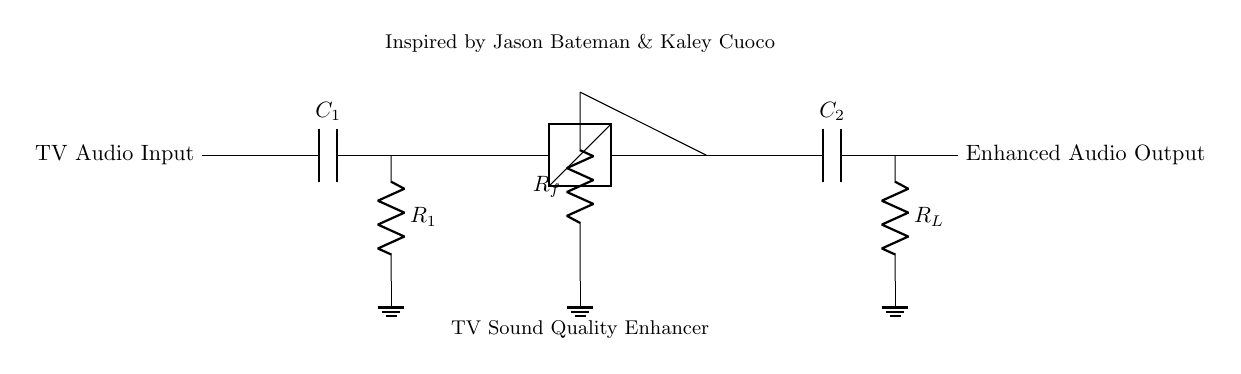What is the first component in the circuit? The circuit shows that the first component is a capacitor labeled C1, which is connected directly to the TV audio input.
Answer: C1 What type of amplifier is shown in the circuit? The circuit includes a component labeled as an "Op-Amp," indicating that this is an operational amplifier used to enhance audio quality.
Answer: Operational amplifier What is the purpose of resistor Rf in the circuit? Resistor Rf is connected to the op-amp and is part of the feedback mechanism, typically influencing the gain of the amplifier.
Answer: Gain adjustment How many capacitors are in the circuit? The diagram displays two capacitors, C1 and C2, used at different points in the audio signal path.
Answer: 2 What connects the output of the op-amp to Rl? The output of the op-amp is connected to Rl (the load resistor) through a short connection, allowing the amplified signal to pass through to the load.
Answer: A short connection What is located at the enhanced audio output? At the enhanced audio output, the signal has already passed through the circuit and is now ready for further transmission or use, meaning it's the final output after amplification.
Answer: Enhanced audio output What is the role of the capacitor C2 at the output? Capacitor C2, located at the output, serves to smooth or filter the amplified audio signal, improving the overall quality by removing any unwanted noise or fluctuations.
Answer: Signal smoothing 